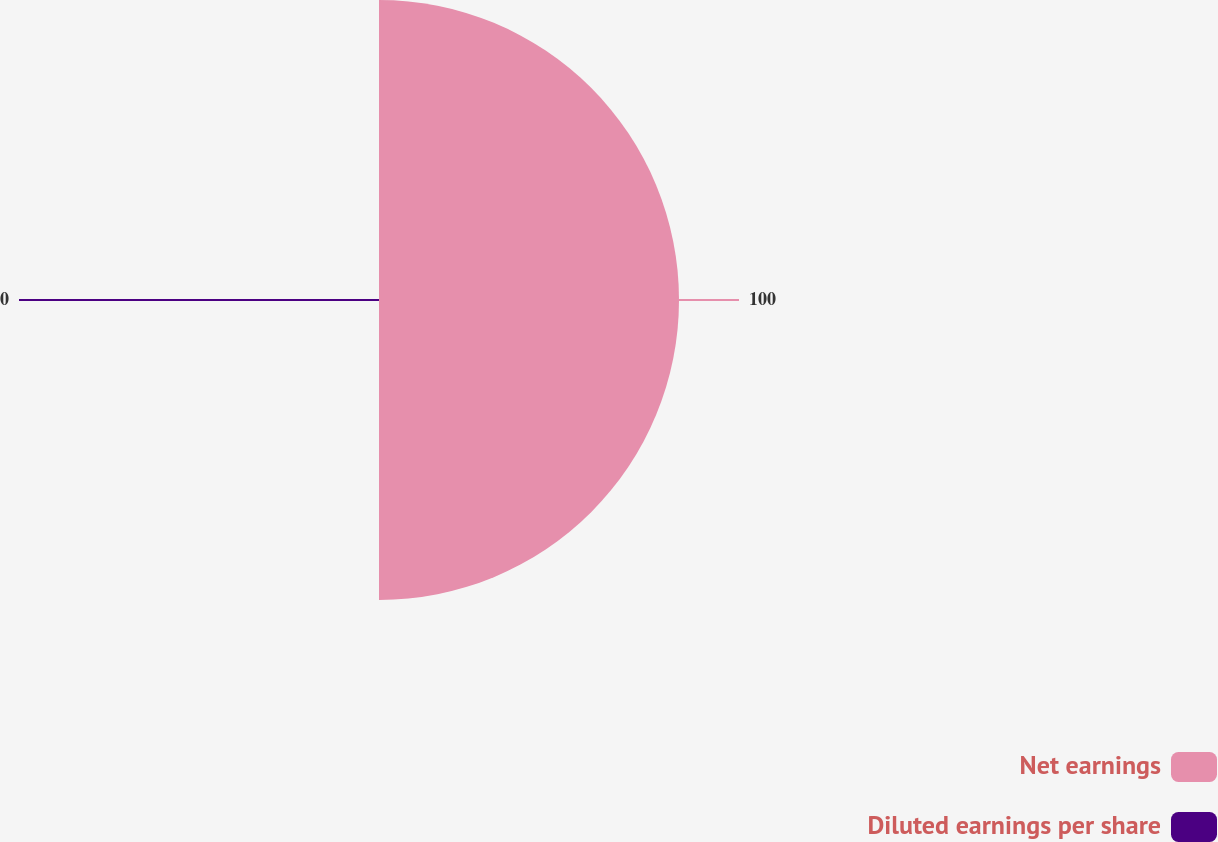<chart> <loc_0><loc_0><loc_500><loc_500><pie_chart><fcel>Net earnings<fcel>Diluted earnings per share<nl><fcel>100.0%<fcel>0.0%<nl></chart> 